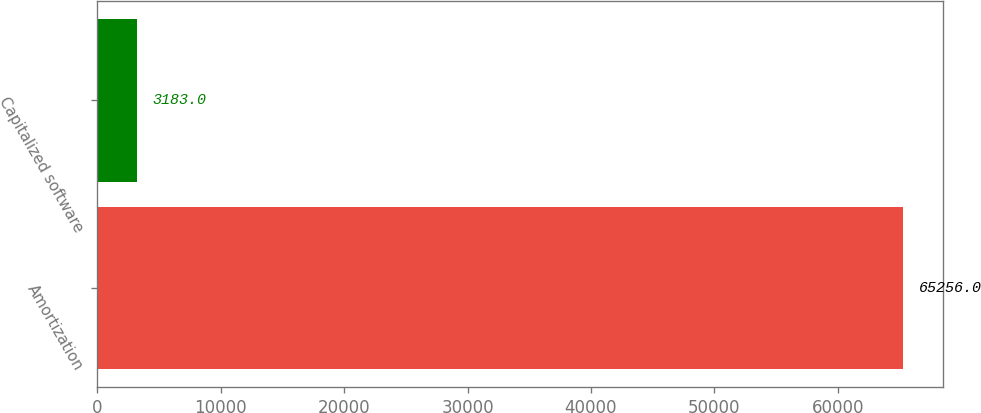Convert chart. <chart><loc_0><loc_0><loc_500><loc_500><bar_chart><fcel>Amortization<fcel>Capitalized software<nl><fcel>65256<fcel>3183<nl></chart> 